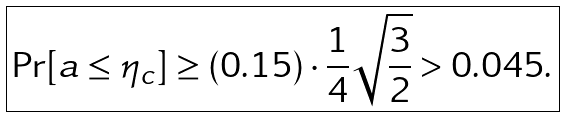<formula> <loc_0><loc_0><loc_500><loc_500>\boxed { \Pr [ a \leq \eta _ { c } ] \geq ( 0 . 1 5 ) \cdot \frac { 1 } { 4 } \sqrt { \frac { 3 } { 2 } } > 0 . 0 4 5 . }</formula> 